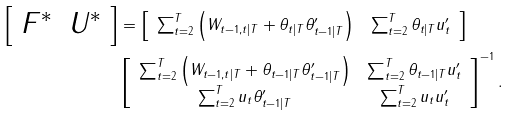Convert formula to latex. <formula><loc_0><loc_0><loc_500><loc_500>\left [ \begin{array} { c c } F ^ { \ast } & U ^ { \ast } \end{array} \right ] & = \left [ \begin{array} { c c } \sum _ { t = 2 } ^ { T } \left ( W _ { t - 1 , t | T } + \theta _ { t | T } \theta _ { t - 1 | T } ^ { \prime } \right ) & \sum _ { t = 2 } ^ { T } \theta _ { t | T } u _ { t } ^ { \prime } \end{array} \right ] \\ & \left [ \begin{array} { c c } \sum _ { t = 2 } ^ { T } \left ( W _ { t - 1 , t | T } + \theta _ { t - 1 | T } \theta _ { t - 1 | T } ^ { \prime } \right ) & \sum _ { t = 2 } ^ { T } \theta _ { t - 1 | T } u _ { t } ^ { \prime } \\ \sum _ { t = 2 } ^ { T } u _ { t } \theta _ { t - 1 | T } ^ { \prime } & \sum _ { t = 2 } ^ { T } u _ { t } u _ { t } ^ { \prime } \end{array} \right ] ^ { - 1 } .</formula> 